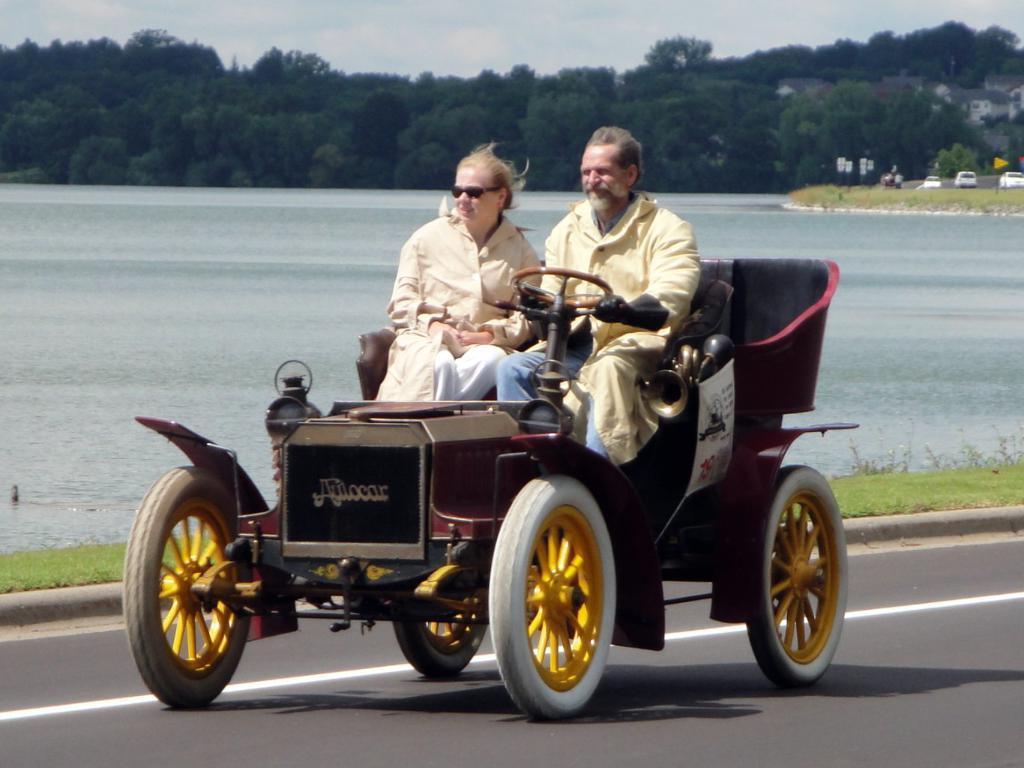In one or two sentences, can you explain what this image depicts? In the picture there is a vehicle , a man is riding the vehicle and beside him a woman is sitting in the background there is a lake, lot of trees,some vehicles and sky. 